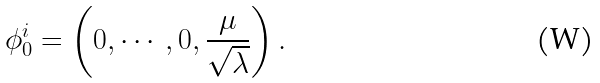<formula> <loc_0><loc_0><loc_500><loc_500>\phi _ { 0 } ^ { i } = \left ( 0 , \cdots , 0 , { \frac { \mu } { \sqrt { \lambda } } } \right ) .</formula> 